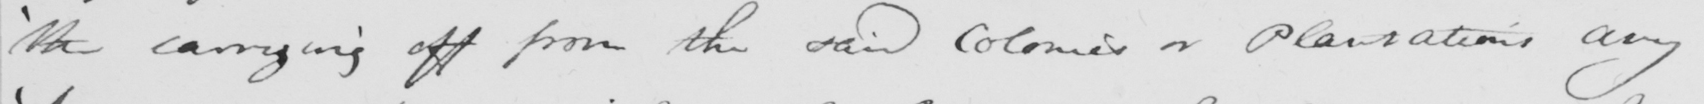What is written in this line of handwriting? ' the carrying off from the said Colonies or Plantations any 